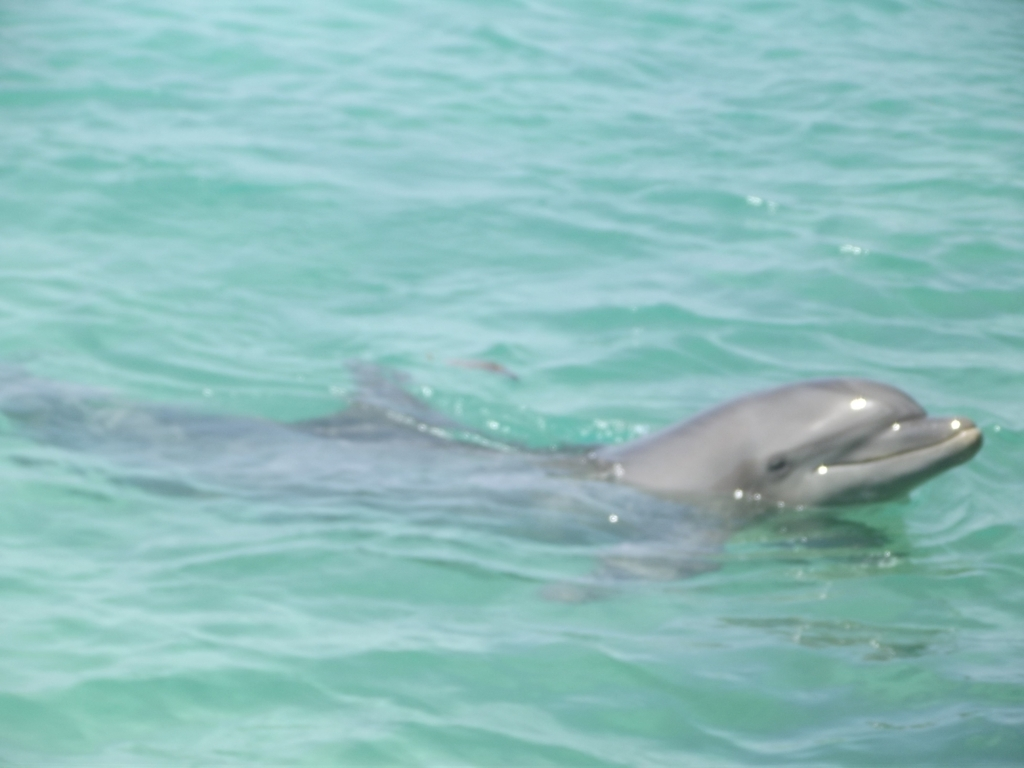Are there any quality issues with this image? Yes, the image appears slightly blurred, which affects the sharpness and detail of the dolphin in the water. This can happen due to motion, insufficient focus, or camera shake during the capture of the photo. Furthermore, the lighting seems to be quite flat which may diminish the visual depth and contrast. 